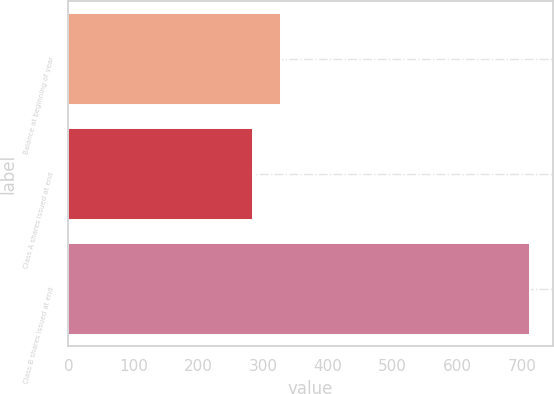Convert chart to OTSL. <chart><loc_0><loc_0><loc_500><loc_500><bar_chart><fcel>Balance at beginning of year<fcel>Class A shares issued at end<fcel>Class B shares issued at end<nl><fcel>327.6<fcel>285<fcel>711<nl></chart> 